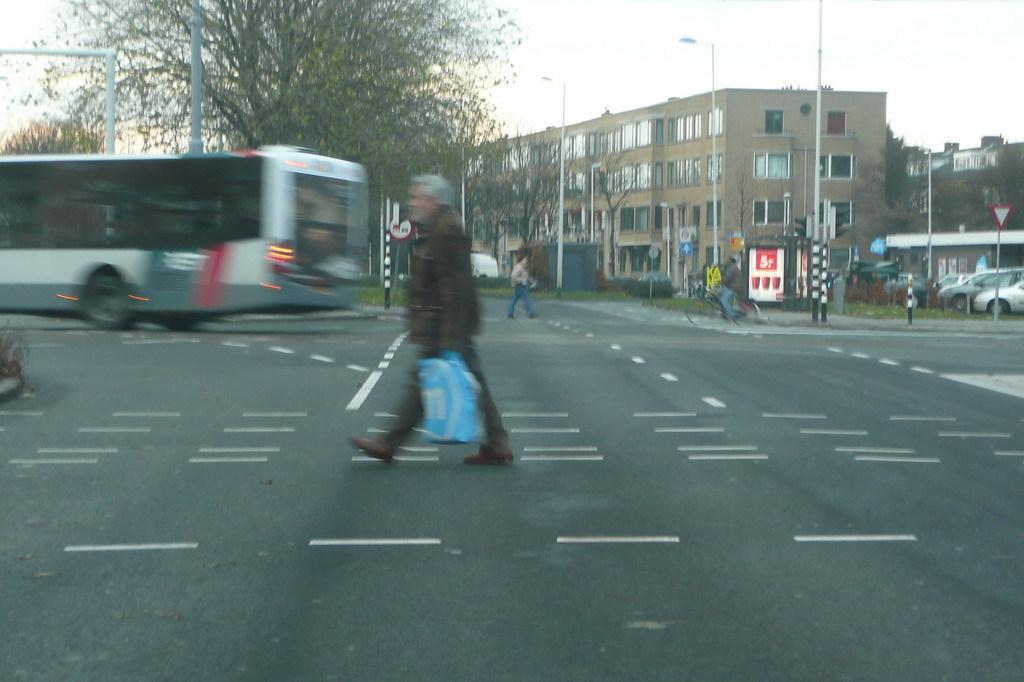Describe this image in one or two sentences. In the foreground of this image, there is a man holding an object is walking on the road and in the background, there is a vehicle moving on it. We can also see the trees, poles, buildings, vehicles, a man walking on the road and a person cycling. At the top, there is the sky. 